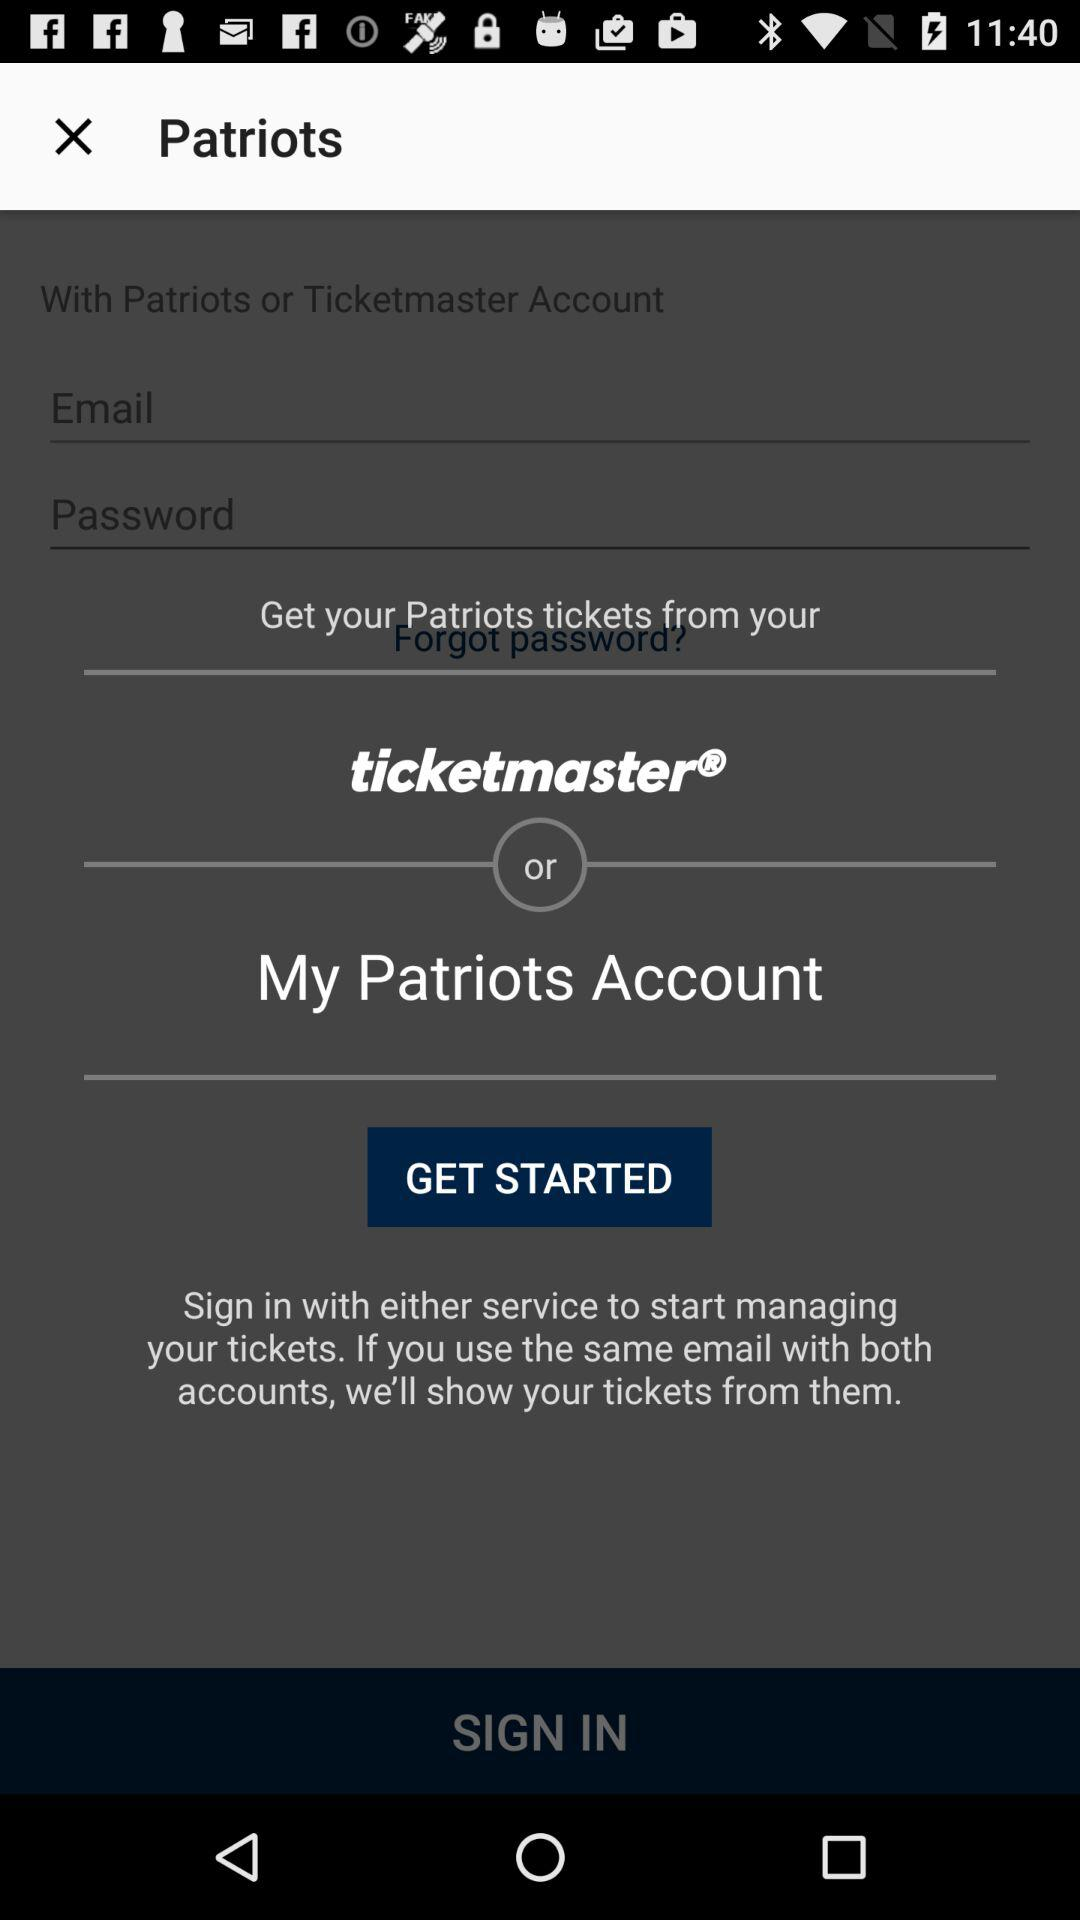What is the application name? The application name is "ticketmaster". 